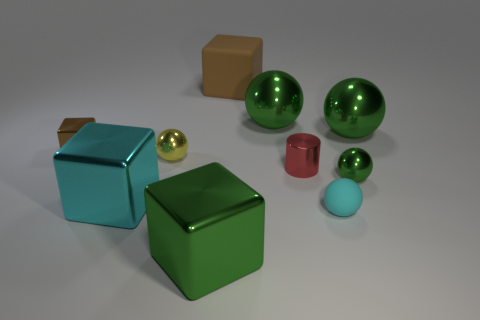Is there a thing of the same size as the red metal cylinder? Yes, the light blue sphere appears to be of similar size to the red metal cylinder. 